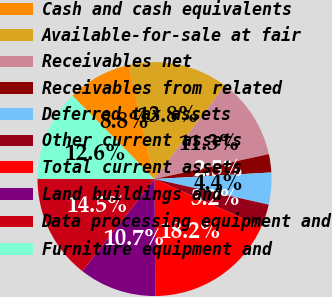Convert chart to OTSL. <chart><loc_0><loc_0><loc_500><loc_500><pie_chart><fcel>Cash and cash equivalents<fcel>Available-for-sale at fair<fcel>Receivables net<fcel>Receivables from related<fcel>Deferred tax assets<fcel>Other current assets<fcel>Total current assets<fcel>Land buildings and<fcel>Data processing equipment and<fcel>Furniture equipment and<nl><fcel>8.81%<fcel>13.83%<fcel>11.32%<fcel>2.52%<fcel>4.41%<fcel>3.15%<fcel>18.23%<fcel>10.69%<fcel>14.46%<fcel>12.58%<nl></chart> 